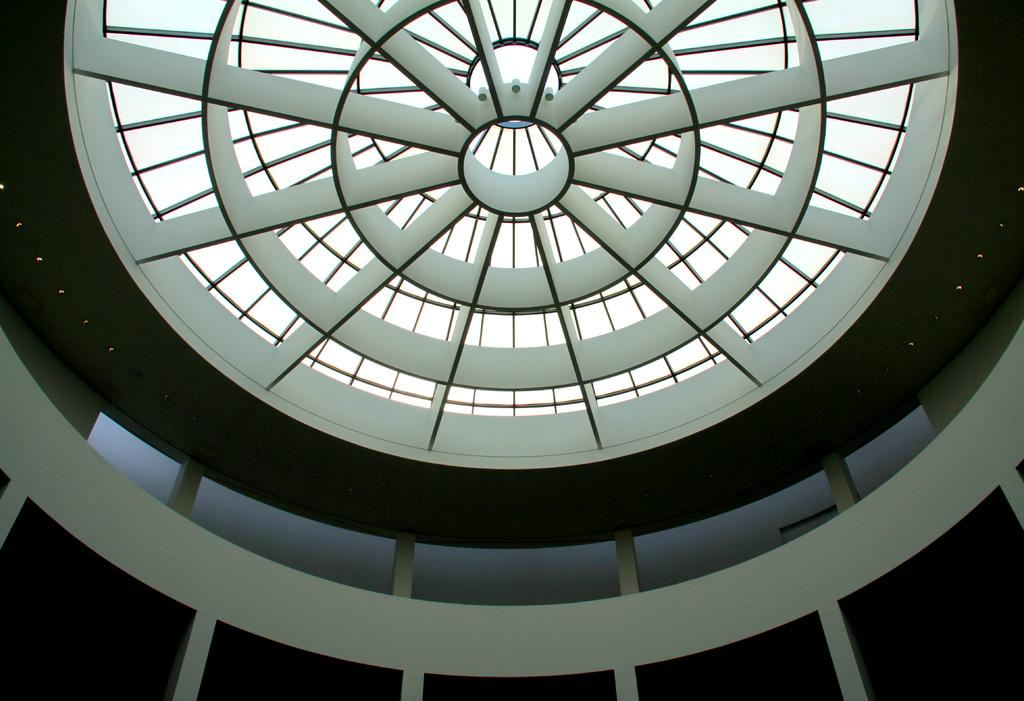What type of design can be seen on the ceiling in the image? There is a ceiling with round shape designs in the image. What is attached to the ceiling? There are lights on the ceiling. What architectural features are present in the image? There are pillars in the image. What surrounds the space in the image? There are walls in the image. How many hens are sitting on the pillars in the image? There are no hens present in the image; it only features a ceiling, lights, pillars, and walls. 